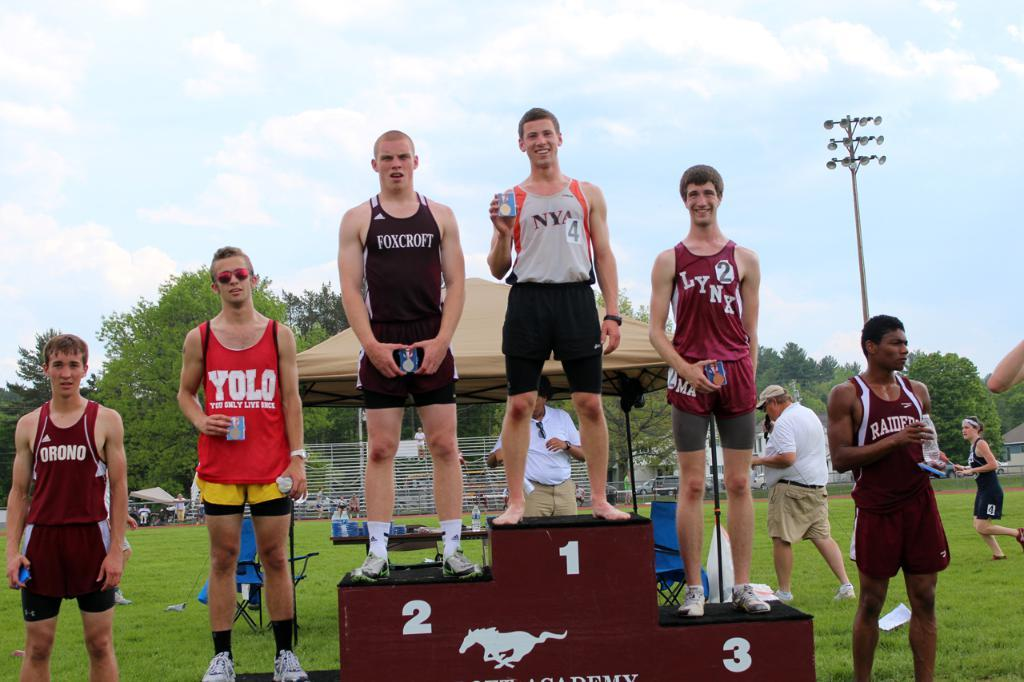Provide a one-sentence caption for the provided image. The athlete from NYA takes the top place at the podium during a track and field event. 